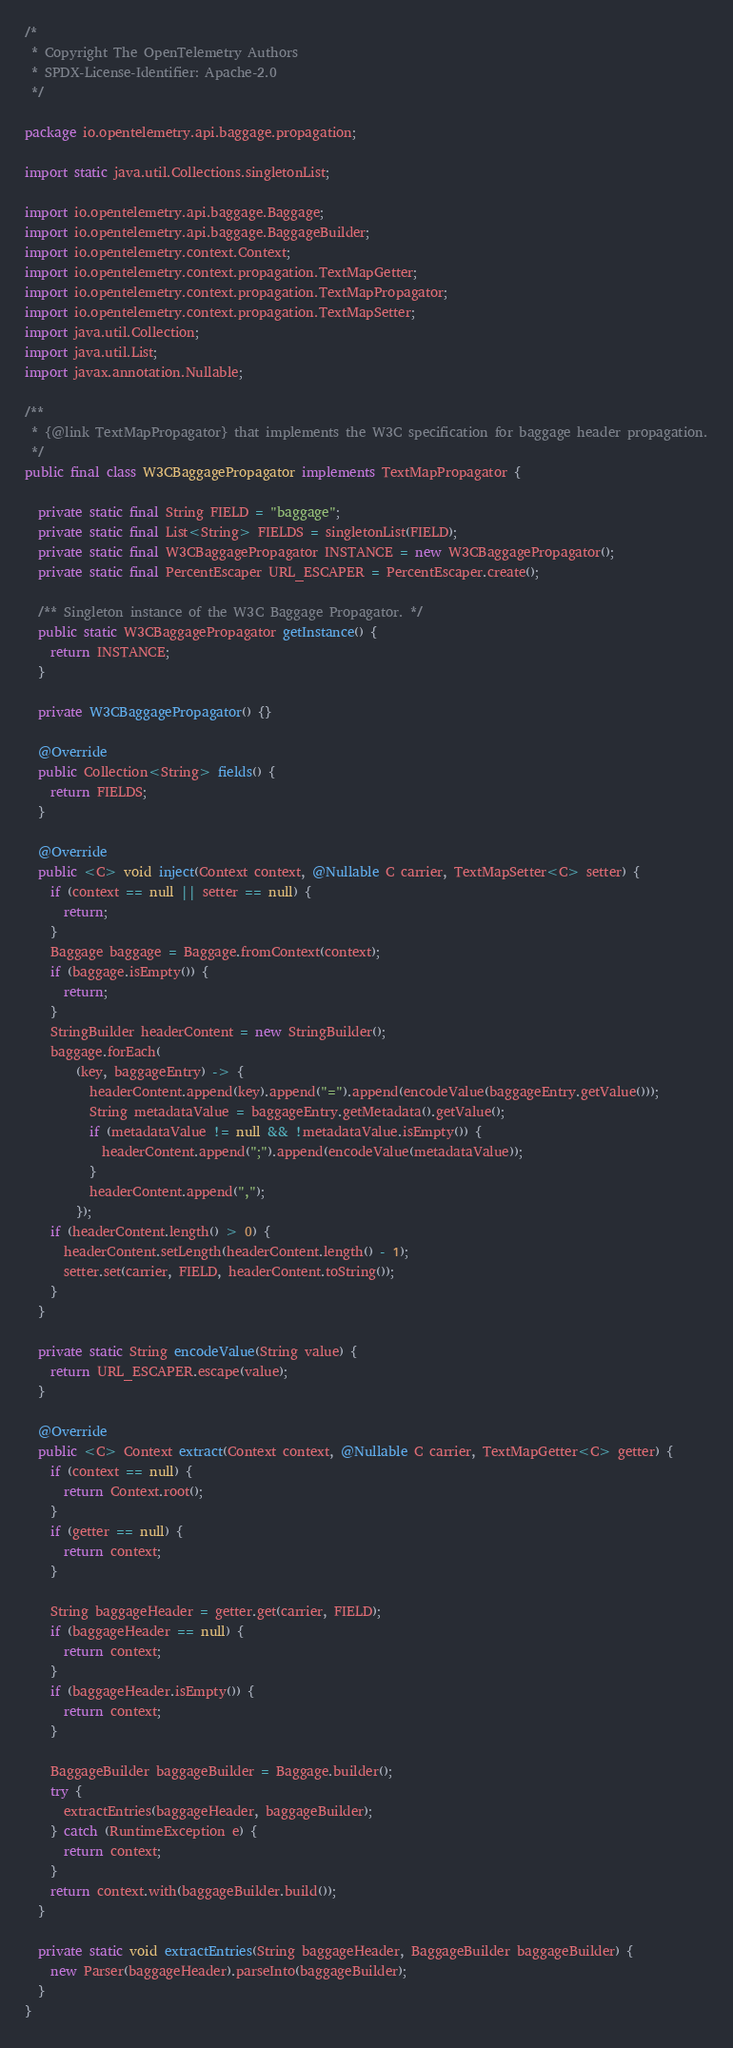<code> <loc_0><loc_0><loc_500><loc_500><_Java_>/*
 * Copyright The OpenTelemetry Authors
 * SPDX-License-Identifier: Apache-2.0
 */

package io.opentelemetry.api.baggage.propagation;

import static java.util.Collections.singletonList;

import io.opentelemetry.api.baggage.Baggage;
import io.opentelemetry.api.baggage.BaggageBuilder;
import io.opentelemetry.context.Context;
import io.opentelemetry.context.propagation.TextMapGetter;
import io.opentelemetry.context.propagation.TextMapPropagator;
import io.opentelemetry.context.propagation.TextMapSetter;
import java.util.Collection;
import java.util.List;
import javax.annotation.Nullable;

/**
 * {@link TextMapPropagator} that implements the W3C specification for baggage header propagation.
 */
public final class W3CBaggagePropagator implements TextMapPropagator {

  private static final String FIELD = "baggage";
  private static final List<String> FIELDS = singletonList(FIELD);
  private static final W3CBaggagePropagator INSTANCE = new W3CBaggagePropagator();
  private static final PercentEscaper URL_ESCAPER = PercentEscaper.create();

  /** Singleton instance of the W3C Baggage Propagator. */
  public static W3CBaggagePropagator getInstance() {
    return INSTANCE;
  }

  private W3CBaggagePropagator() {}

  @Override
  public Collection<String> fields() {
    return FIELDS;
  }

  @Override
  public <C> void inject(Context context, @Nullable C carrier, TextMapSetter<C> setter) {
    if (context == null || setter == null) {
      return;
    }
    Baggage baggage = Baggage.fromContext(context);
    if (baggage.isEmpty()) {
      return;
    }
    StringBuilder headerContent = new StringBuilder();
    baggage.forEach(
        (key, baggageEntry) -> {
          headerContent.append(key).append("=").append(encodeValue(baggageEntry.getValue()));
          String metadataValue = baggageEntry.getMetadata().getValue();
          if (metadataValue != null && !metadataValue.isEmpty()) {
            headerContent.append(";").append(encodeValue(metadataValue));
          }
          headerContent.append(",");
        });
    if (headerContent.length() > 0) {
      headerContent.setLength(headerContent.length() - 1);
      setter.set(carrier, FIELD, headerContent.toString());
    }
  }

  private static String encodeValue(String value) {
    return URL_ESCAPER.escape(value);
  }

  @Override
  public <C> Context extract(Context context, @Nullable C carrier, TextMapGetter<C> getter) {
    if (context == null) {
      return Context.root();
    }
    if (getter == null) {
      return context;
    }

    String baggageHeader = getter.get(carrier, FIELD);
    if (baggageHeader == null) {
      return context;
    }
    if (baggageHeader.isEmpty()) {
      return context;
    }

    BaggageBuilder baggageBuilder = Baggage.builder();
    try {
      extractEntries(baggageHeader, baggageBuilder);
    } catch (RuntimeException e) {
      return context;
    }
    return context.with(baggageBuilder.build());
  }

  private static void extractEntries(String baggageHeader, BaggageBuilder baggageBuilder) {
    new Parser(baggageHeader).parseInto(baggageBuilder);
  }
}
</code> 